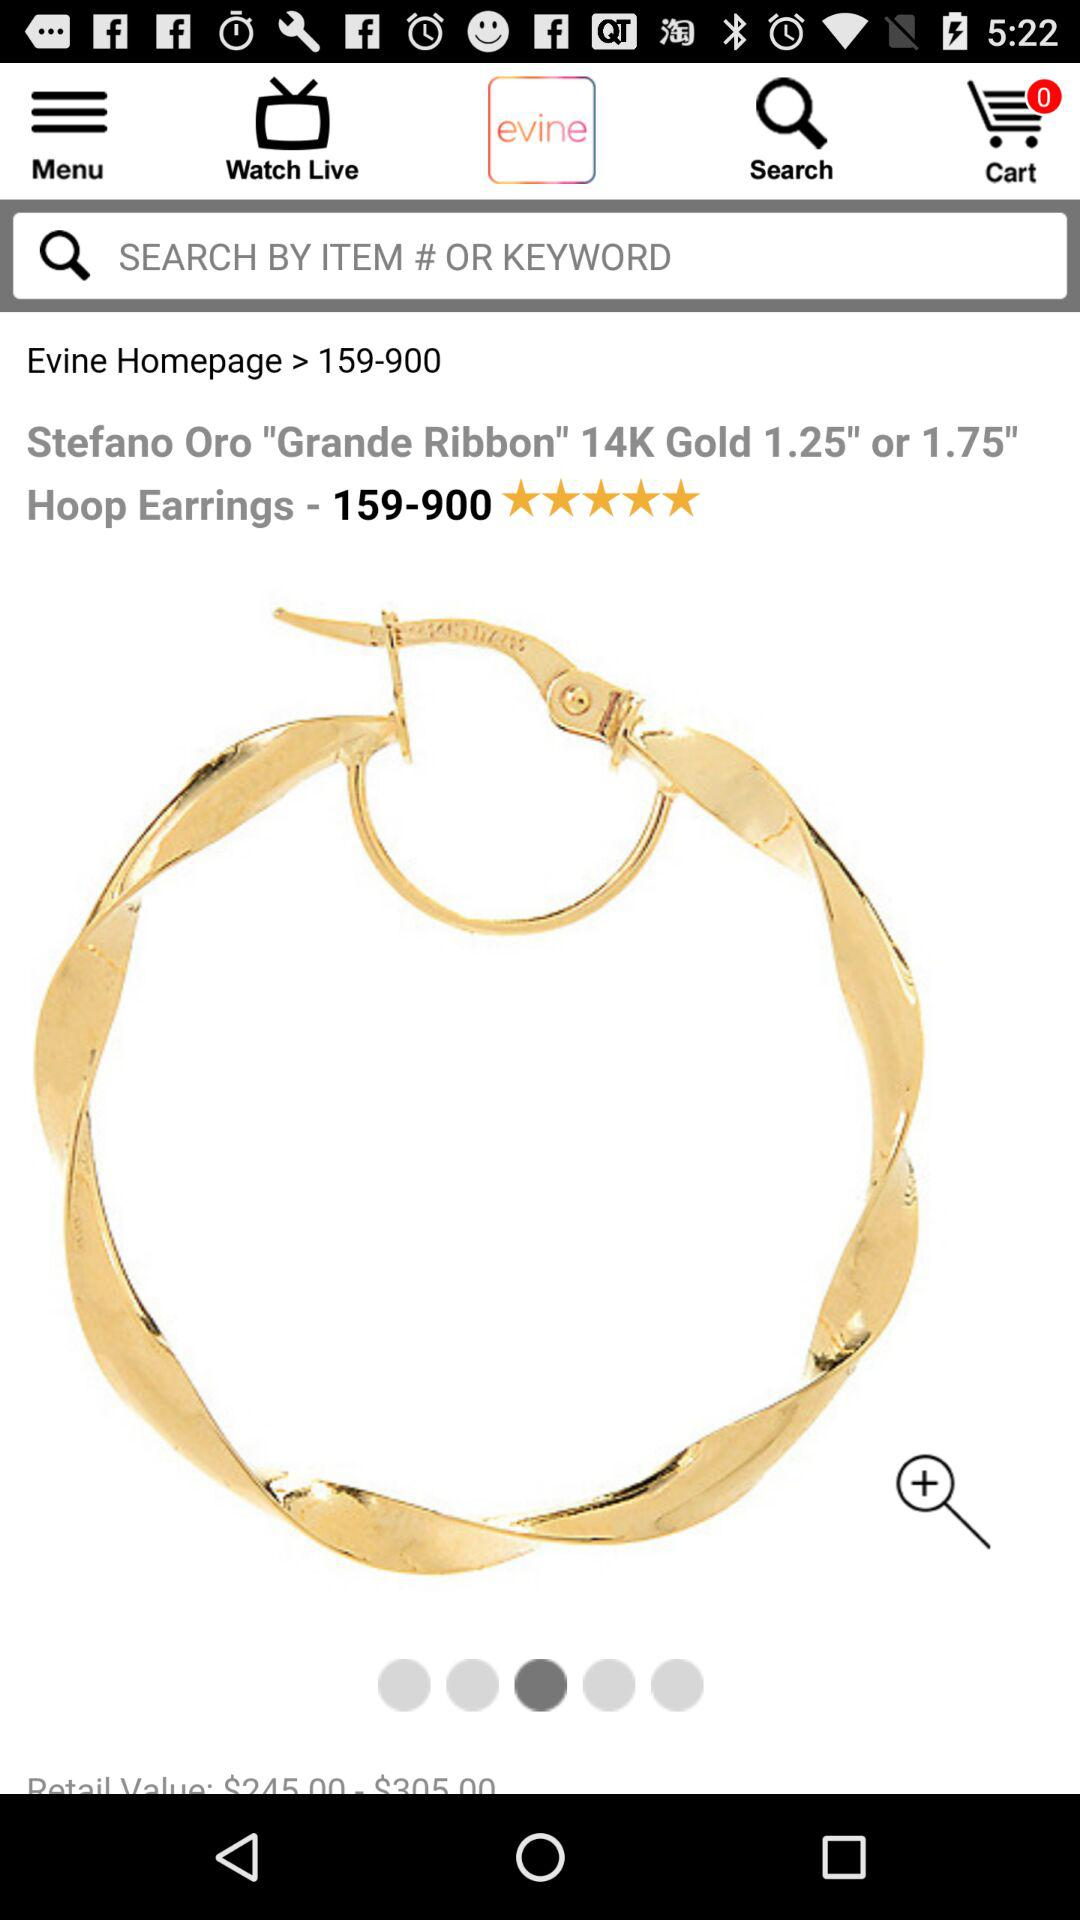What is the retail value of the product?
Answer the question using a single word or phrase. $245.00 - $305.00 